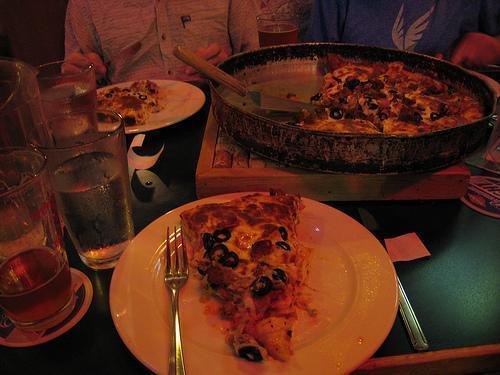How many forks are there?
Give a very brief answer. 1. 